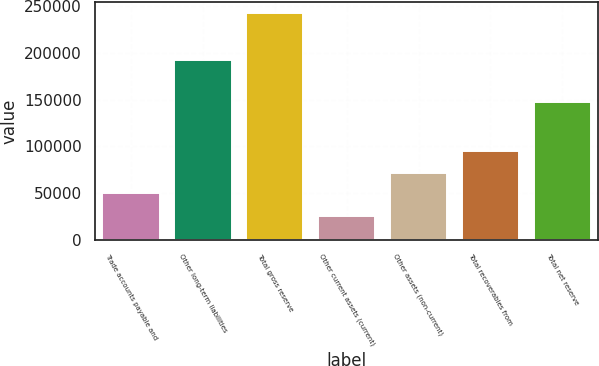<chart> <loc_0><loc_0><loc_500><loc_500><bar_chart><fcel>Trade accounts payable and<fcel>Other long-term liabilities<fcel>Total gross reserve<fcel>Other current assets (current)<fcel>Other assets (non-current)<fcel>Total recoverables from<fcel>Total net reserve<nl><fcel>49594<fcel>192922<fcel>242516<fcel>25248<fcel>71320.8<fcel>95008<fcel>147508<nl></chart> 